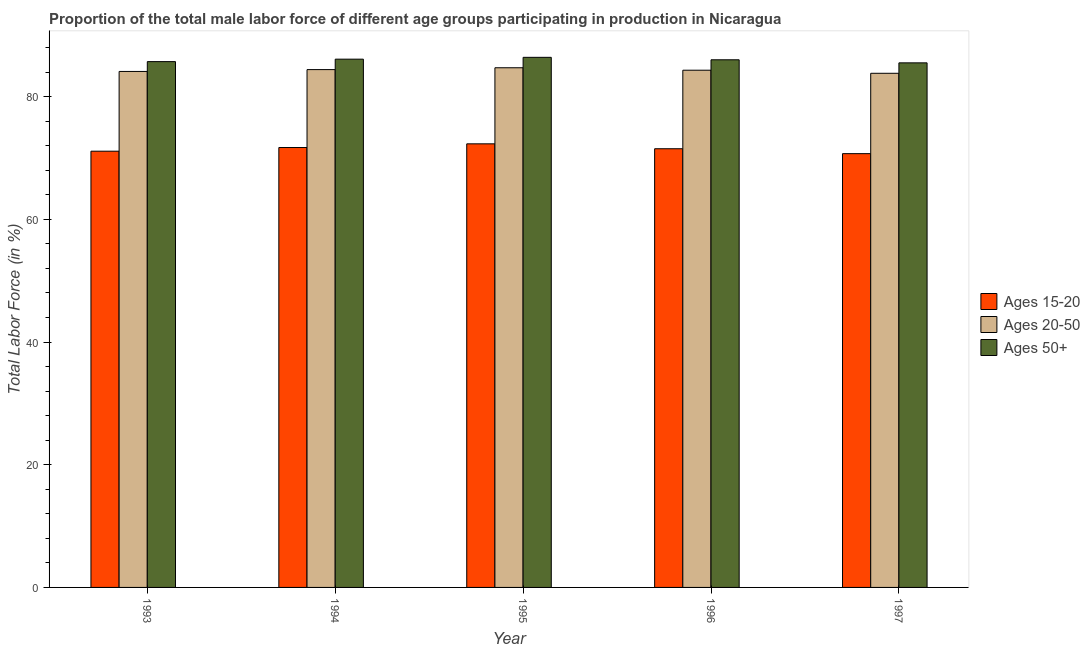How many different coloured bars are there?
Offer a very short reply. 3. How many bars are there on the 4th tick from the left?
Your answer should be very brief. 3. What is the label of the 1st group of bars from the left?
Provide a short and direct response. 1993. In how many cases, is the number of bars for a given year not equal to the number of legend labels?
Make the answer very short. 0. What is the percentage of male labor force within the age group 20-50 in 1996?
Provide a succinct answer. 84.3. Across all years, what is the maximum percentage of male labor force within the age group 15-20?
Give a very brief answer. 72.3. Across all years, what is the minimum percentage of male labor force above age 50?
Your response must be concise. 85.5. What is the total percentage of male labor force within the age group 15-20 in the graph?
Your answer should be compact. 357.3. What is the difference between the percentage of male labor force within the age group 20-50 in 1993 and that in 1997?
Keep it short and to the point. 0.3. What is the difference between the percentage of male labor force within the age group 15-20 in 1995 and the percentage of male labor force above age 50 in 1994?
Provide a short and direct response. 0.6. What is the average percentage of male labor force above age 50 per year?
Provide a short and direct response. 85.94. In the year 1995, what is the difference between the percentage of male labor force above age 50 and percentage of male labor force within the age group 15-20?
Your answer should be compact. 0. What is the ratio of the percentage of male labor force within the age group 15-20 in 1993 to that in 1995?
Your answer should be very brief. 0.98. Is the difference between the percentage of male labor force above age 50 in 1993 and 1995 greater than the difference between the percentage of male labor force within the age group 15-20 in 1993 and 1995?
Give a very brief answer. No. What is the difference between the highest and the second highest percentage of male labor force within the age group 15-20?
Your response must be concise. 0.6. What is the difference between the highest and the lowest percentage of male labor force within the age group 15-20?
Give a very brief answer. 1.6. In how many years, is the percentage of male labor force above age 50 greater than the average percentage of male labor force above age 50 taken over all years?
Keep it short and to the point. 3. Is the sum of the percentage of male labor force within the age group 20-50 in 1994 and 1995 greater than the maximum percentage of male labor force within the age group 15-20 across all years?
Offer a very short reply. Yes. What does the 3rd bar from the left in 1996 represents?
Ensure brevity in your answer.  Ages 50+. What does the 2nd bar from the right in 1997 represents?
Keep it short and to the point. Ages 20-50. How many bars are there?
Your answer should be compact. 15. Are the values on the major ticks of Y-axis written in scientific E-notation?
Keep it short and to the point. No. Does the graph contain grids?
Your answer should be compact. No. How many legend labels are there?
Your response must be concise. 3. How are the legend labels stacked?
Offer a terse response. Vertical. What is the title of the graph?
Offer a terse response. Proportion of the total male labor force of different age groups participating in production in Nicaragua. Does "Capital account" appear as one of the legend labels in the graph?
Give a very brief answer. No. What is the label or title of the X-axis?
Provide a succinct answer. Year. What is the label or title of the Y-axis?
Your response must be concise. Total Labor Force (in %). What is the Total Labor Force (in %) in Ages 15-20 in 1993?
Make the answer very short. 71.1. What is the Total Labor Force (in %) of Ages 20-50 in 1993?
Your response must be concise. 84.1. What is the Total Labor Force (in %) of Ages 50+ in 1993?
Your response must be concise. 85.7. What is the Total Labor Force (in %) of Ages 15-20 in 1994?
Provide a succinct answer. 71.7. What is the Total Labor Force (in %) in Ages 20-50 in 1994?
Your answer should be compact. 84.4. What is the Total Labor Force (in %) of Ages 50+ in 1994?
Ensure brevity in your answer.  86.1. What is the Total Labor Force (in %) of Ages 15-20 in 1995?
Your answer should be very brief. 72.3. What is the Total Labor Force (in %) of Ages 20-50 in 1995?
Your answer should be compact. 84.7. What is the Total Labor Force (in %) in Ages 50+ in 1995?
Your answer should be very brief. 86.4. What is the Total Labor Force (in %) in Ages 15-20 in 1996?
Provide a succinct answer. 71.5. What is the Total Labor Force (in %) in Ages 20-50 in 1996?
Your answer should be compact. 84.3. What is the Total Labor Force (in %) in Ages 15-20 in 1997?
Ensure brevity in your answer.  70.7. What is the Total Labor Force (in %) of Ages 20-50 in 1997?
Keep it short and to the point. 83.8. What is the Total Labor Force (in %) of Ages 50+ in 1997?
Your response must be concise. 85.5. Across all years, what is the maximum Total Labor Force (in %) in Ages 15-20?
Your answer should be compact. 72.3. Across all years, what is the maximum Total Labor Force (in %) in Ages 20-50?
Your answer should be very brief. 84.7. Across all years, what is the maximum Total Labor Force (in %) in Ages 50+?
Make the answer very short. 86.4. Across all years, what is the minimum Total Labor Force (in %) in Ages 15-20?
Make the answer very short. 70.7. Across all years, what is the minimum Total Labor Force (in %) of Ages 20-50?
Ensure brevity in your answer.  83.8. Across all years, what is the minimum Total Labor Force (in %) in Ages 50+?
Offer a very short reply. 85.5. What is the total Total Labor Force (in %) in Ages 15-20 in the graph?
Ensure brevity in your answer.  357.3. What is the total Total Labor Force (in %) in Ages 20-50 in the graph?
Ensure brevity in your answer.  421.3. What is the total Total Labor Force (in %) in Ages 50+ in the graph?
Offer a very short reply. 429.7. What is the difference between the Total Labor Force (in %) in Ages 50+ in 1993 and that in 1994?
Keep it short and to the point. -0.4. What is the difference between the Total Labor Force (in %) in Ages 20-50 in 1993 and that in 1995?
Give a very brief answer. -0.6. What is the difference between the Total Labor Force (in %) of Ages 50+ in 1993 and that in 1995?
Give a very brief answer. -0.7. What is the difference between the Total Labor Force (in %) of Ages 15-20 in 1993 and that in 1996?
Your answer should be compact. -0.4. What is the difference between the Total Labor Force (in %) of Ages 20-50 in 1993 and that in 1996?
Give a very brief answer. -0.2. What is the difference between the Total Labor Force (in %) of Ages 15-20 in 1993 and that in 1997?
Your answer should be compact. 0.4. What is the difference between the Total Labor Force (in %) in Ages 50+ in 1993 and that in 1997?
Keep it short and to the point. 0.2. What is the difference between the Total Labor Force (in %) of Ages 15-20 in 1994 and that in 1995?
Keep it short and to the point. -0.6. What is the difference between the Total Labor Force (in %) in Ages 15-20 in 1994 and that in 1996?
Make the answer very short. 0.2. What is the difference between the Total Labor Force (in %) in Ages 50+ in 1994 and that in 1996?
Give a very brief answer. 0.1. What is the difference between the Total Labor Force (in %) in Ages 20-50 in 1994 and that in 1997?
Offer a terse response. 0.6. What is the difference between the Total Labor Force (in %) of Ages 20-50 in 1995 and that in 1996?
Your response must be concise. 0.4. What is the difference between the Total Labor Force (in %) in Ages 50+ in 1995 and that in 1996?
Offer a terse response. 0.4. What is the difference between the Total Labor Force (in %) in Ages 20-50 in 1995 and that in 1997?
Your answer should be very brief. 0.9. What is the difference between the Total Labor Force (in %) of Ages 15-20 in 1996 and that in 1997?
Make the answer very short. 0.8. What is the difference between the Total Labor Force (in %) in Ages 15-20 in 1993 and the Total Labor Force (in %) in Ages 50+ in 1994?
Offer a terse response. -15. What is the difference between the Total Labor Force (in %) of Ages 15-20 in 1993 and the Total Labor Force (in %) of Ages 20-50 in 1995?
Make the answer very short. -13.6. What is the difference between the Total Labor Force (in %) in Ages 15-20 in 1993 and the Total Labor Force (in %) in Ages 50+ in 1995?
Your response must be concise. -15.3. What is the difference between the Total Labor Force (in %) in Ages 15-20 in 1993 and the Total Labor Force (in %) in Ages 50+ in 1996?
Provide a short and direct response. -14.9. What is the difference between the Total Labor Force (in %) in Ages 20-50 in 1993 and the Total Labor Force (in %) in Ages 50+ in 1996?
Provide a short and direct response. -1.9. What is the difference between the Total Labor Force (in %) of Ages 15-20 in 1993 and the Total Labor Force (in %) of Ages 20-50 in 1997?
Offer a very short reply. -12.7. What is the difference between the Total Labor Force (in %) of Ages 15-20 in 1993 and the Total Labor Force (in %) of Ages 50+ in 1997?
Provide a short and direct response. -14.4. What is the difference between the Total Labor Force (in %) of Ages 15-20 in 1994 and the Total Labor Force (in %) of Ages 20-50 in 1995?
Your answer should be very brief. -13. What is the difference between the Total Labor Force (in %) of Ages 15-20 in 1994 and the Total Labor Force (in %) of Ages 50+ in 1995?
Provide a succinct answer. -14.7. What is the difference between the Total Labor Force (in %) in Ages 15-20 in 1994 and the Total Labor Force (in %) in Ages 50+ in 1996?
Your answer should be compact. -14.3. What is the difference between the Total Labor Force (in %) in Ages 20-50 in 1994 and the Total Labor Force (in %) in Ages 50+ in 1996?
Provide a short and direct response. -1.6. What is the difference between the Total Labor Force (in %) in Ages 15-20 in 1994 and the Total Labor Force (in %) in Ages 20-50 in 1997?
Keep it short and to the point. -12.1. What is the difference between the Total Labor Force (in %) of Ages 20-50 in 1994 and the Total Labor Force (in %) of Ages 50+ in 1997?
Keep it short and to the point. -1.1. What is the difference between the Total Labor Force (in %) of Ages 15-20 in 1995 and the Total Labor Force (in %) of Ages 50+ in 1996?
Offer a terse response. -13.7. What is the difference between the Total Labor Force (in %) in Ages 15-20 in 1996 and the Total Labor Force (in %) in Ages 50+ in 1997?
Offer a very short reply. -14. What is the average Total Labor Force (in %) of Ages 15-20 per year?
Your answer should be compact. 71.46. What is the average Total Labor Force (in %) in Ages 20-50 per year?
Your answer should be very brief. 84.26. What is the average Total Labor Force (in %) of Ages 50+ per year?
Your answer should be compact. 85.94. In the year 1993, what is the difference between the Total Labor Force (in %) in Ages 15-20 and Total Labor Force (in %) in Ages 20-50?
Make the answer very short. -13. In the year 1993, what is the difference between the Total Labor Force (in %) of Ages 15-20 and Total Labor Force (in %) of Ages 50+?
Make the answer very short. -14.6. In the year 1994, what is the difference between the Total Labor Force (in %) in Ages 15-20 and Total Labor Force (in %) in Ages 20-50?
Keep it short and to the point. -12.7. In the year 1994, what is the difference between the Total Labor Force (in %) in Ages 15-20 and Total Labor Force (in %) in Ages 50+?
Make the answer very short. -14.4. In the year 1994, what is the difference between the Total Labor Force (in %) in Ages 20-50 and Total Labor Force (in %) in Ages 50+?
Give a very brief answer. -1.7. In the year 1995, what is the difference between the Total Labor Force (in %) in Ages 15-20 and Total Labor Force (in %) in Ages 20-50?
Make the answer very short. -12.4. In the year 1995, what is the difference between the Total Labor Force (in %) of Ages 15-20 and Total Labor Force (in %) of Ages 50+?
Give a very brief answer. -14.1. In the year 1995, what is the difference between the Total Labor Force (in %) in Ages 20-50 and Total Labor Force (in %) in Ages 50+?
Give a very brief answer. -1.7. In the year 1996, what is the difference between the Total Labor Force (in %) of Ages 15-20 and Total Labor Force (in %) of Ages 50+?
Your response must be concise. -14.5. In the year 1996, what is the difference between the Total Labor Force (in %) of Ages 20-50 and Total Labor Force (in %) of Ages 50+?
Your answer should be compact. -1.7. In the year 1997, what is the difference between the Total Labor Force (in %) in Ages 15-20 and Total Labor Force (in %) in Ages 50+?
Your answer should be compact. -14.8. In the year 1997, what is the difference between the Total Labor Force (in %) in Ages 20-50 and Total Labor Force (in %) in Ages 50+?
Give a very brief answer. -1.7. What is the ratio of the Total Labor Force (in %) of Ages 15-20 in 1993 to that in 1994?
Provide a succinct answer. 0.99. What is the ratio of the Total Labor Force (in %) of Ages 20-50 in 1993 to that in 1994?
Provide a succinct answer. 1. What is the ratio of the Total Labor Force (in %) in Ages 15-20 in 1993 to that in 1995?
Offer a very short reply. 0.98. What is the ratio of the Total Labor Force (in %) in Ages 20-50 in 1993 to that in 1995?
Provide a succinct answer. 0.99. What is the ratio of the Total Labor Force (in %) in Ages 15-20 in 1993 to that in 1996?
Your answer should be compact. 0.99. What is the ratio of the Total Labor Force (in %) in Ages 20-50 in 1993 to that in 1996?
Make the answer very short. 1. What is the ratio of the Total Labor Force (in %) of Ages 50+ in 1993 to that in 1996?
Your answer should be very brief. 1. What is the ratio of the Total Labor Force (in %) in Ages 15-20 in 1993 to that in 1997?
Ensure brevity in your answer.  1.01. What is the ratio of the Total Labor Force (in %) of Ages 15-20 in 1994 to that in 1995?
Keep it short and to the point. 0.99. What is the ratio of the Total Labor Force (in %) in Ages 15-20 in 1994 to that in 1996?
Offer a very short reply. 1. What is the ratio of the Total Labor Force (in %) of Ages 20-50 in 1994 to that in 1996?
Your answer should be compact. 1. What is the ratio of the Total Labor Force (in %) of Ages 15-20 in 1994 to that in 1997?
Make the answer very short. 1.01. What is the ratio of the Total Labor Force (in %) in Ages 15-20 in 1995 to that in 1996?
Give a very brief answer. 1.01. What is the ratio of the Total Labor Force (in %) in Ages 50+ in 1995 to that in 1996?
Ensure brevity in your answer.  1. What is the ratio of the Total Labor Force (in %) of Ages 15-20 in 1995 to that in 1997?
Ensure brevity in your answer.  1.02. What is the ratio of the Total Labor Force (in %) in Ages 20-50 in 1995 to that in 1997?
Provide a succinct answer. 1.01. What is the ratio of the Total Labor Force (in %) of Ages 50+ in 1995 to that in 1997?
Ensure brevity in your answer.  1.01. What is the ratio of the Total Labor Force (in %) of Ages 15-20 in 1996 to that in 1997?
Offer a terse response. 1.01. What is the ratio of the Total Labor Force (in %) in Ages 50+ in 1996 to that in 1997?
Keep it short and to the point. 1.01. What is the difference between the highest and the lowest Total Labor Force (in %) in Ages 50+?
Offer a very short reply. 0.9. 